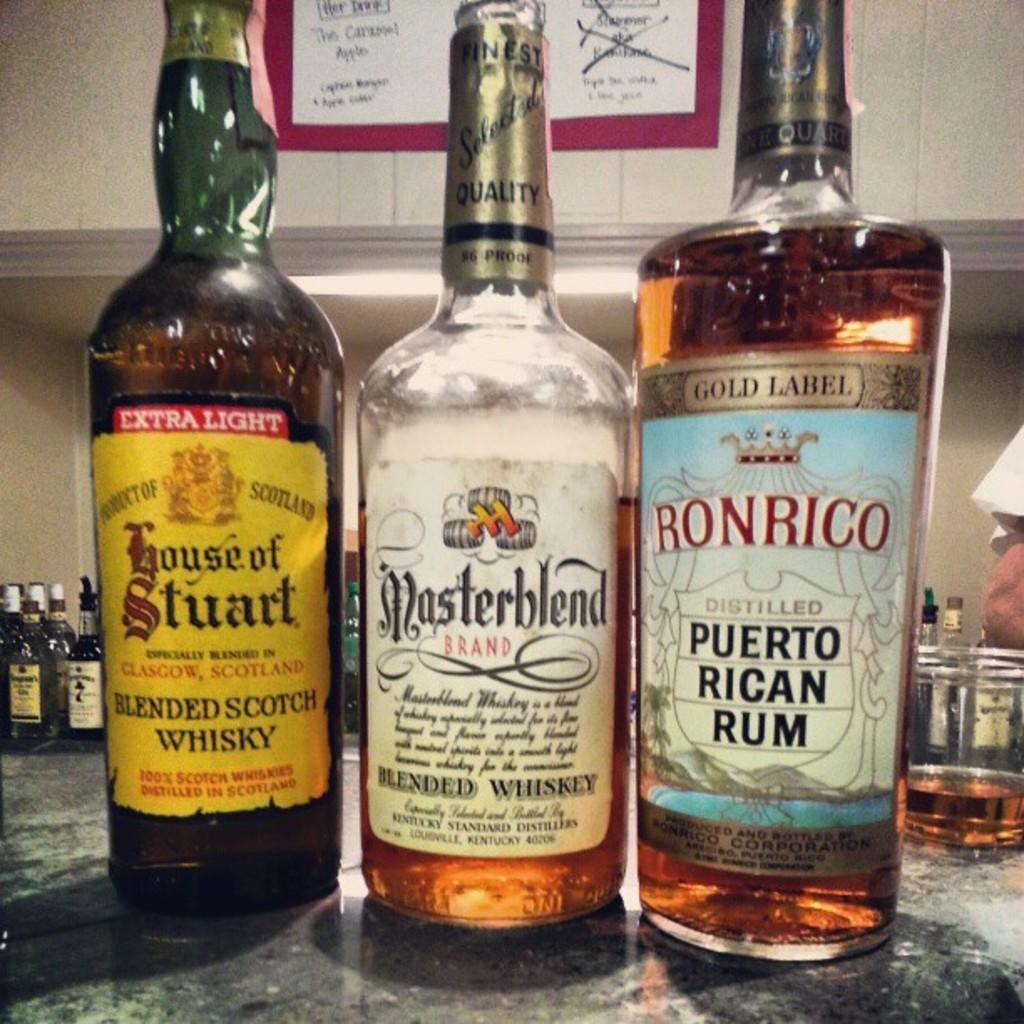<image>
Write a terse but informative summary of the picture. A bottle of Puerto Rican Rum is on a table with other bottles. 